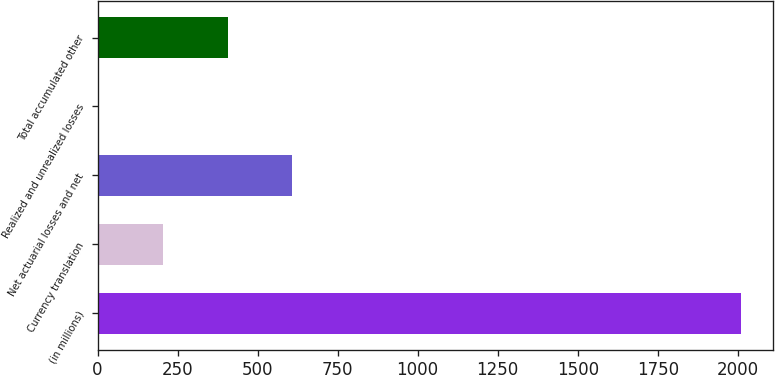<chart> <loc_0><loc_0><loc_500><loc_500><bar_chart><fcel>(in millions)<fcel>Currency translation<fcel>Net actuarial losses and net<fcel>Realized and unrealized losses<fcel>Total accumulated other<nl><fcel>2010<fcel>206.04<fcel>606.92<fcel>5.6<fcel>406.48<nl></chart> 